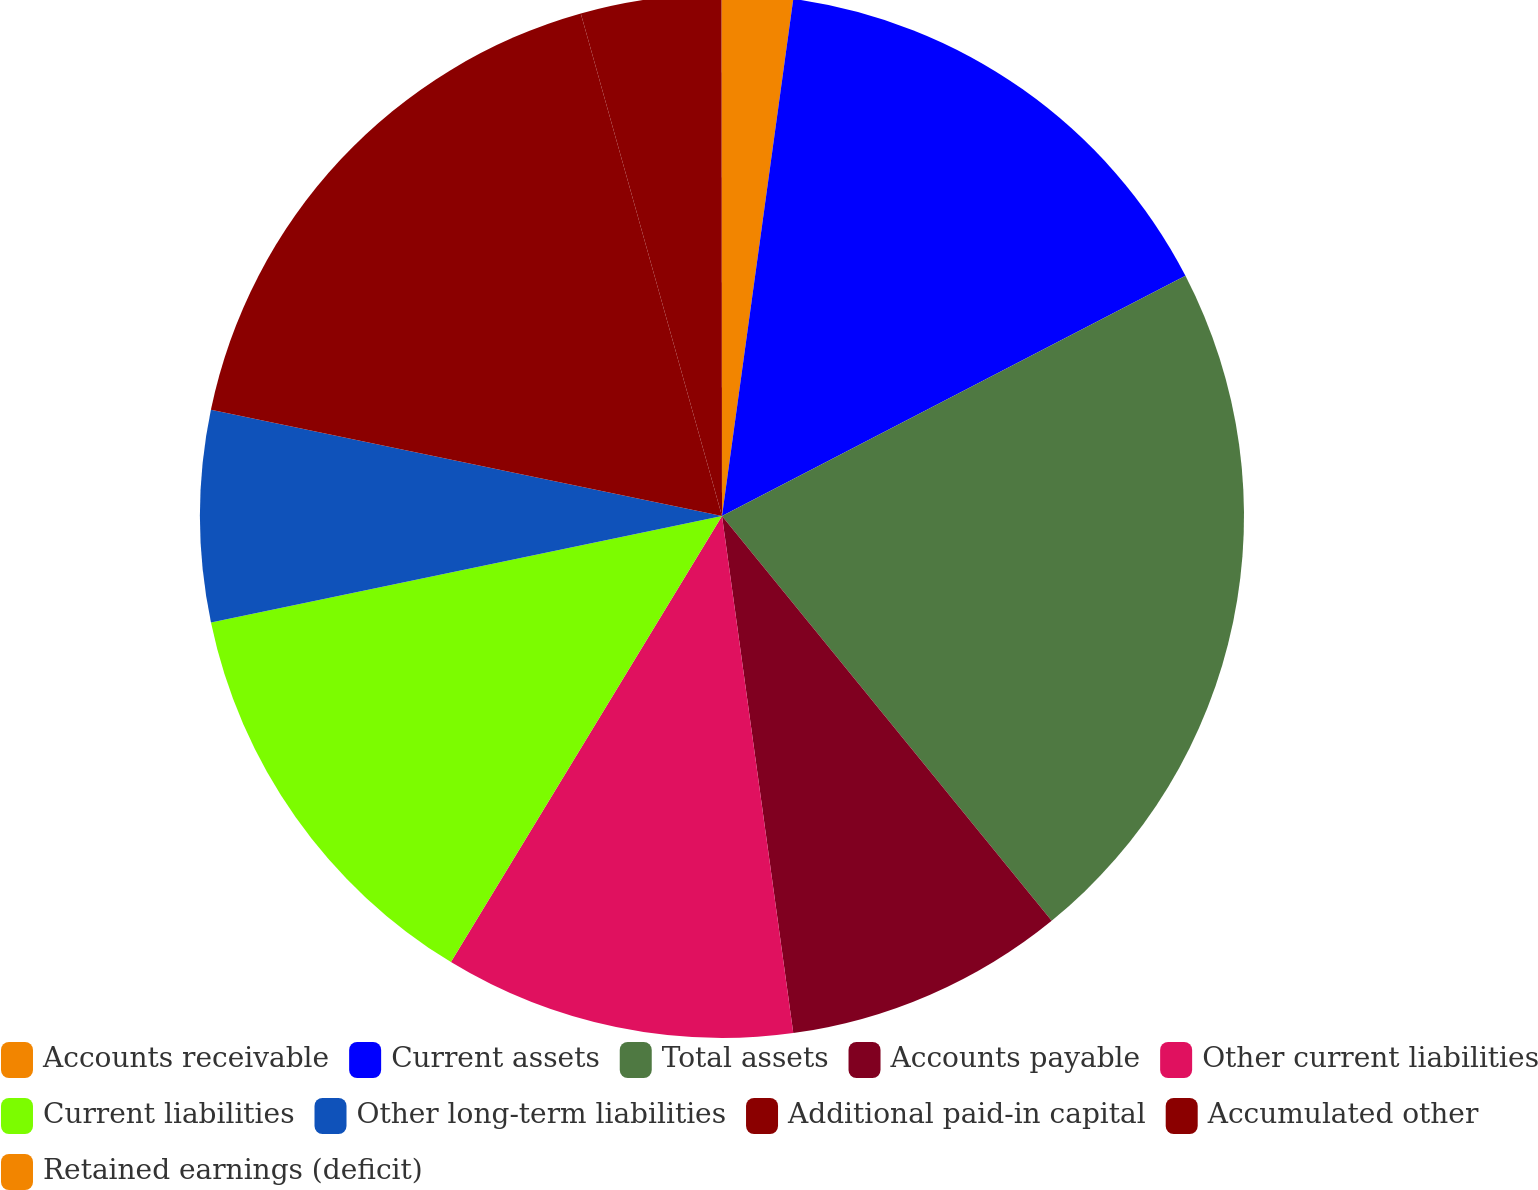<chart> <loc_0><loc_0><loc_500><loc_500><pie_chart><fcel>Accounts receivable<fcel>Current assets<fcel>Total assets<fcel>Accounts payable<fcel>Other current liabilities<fcel>Current liabilities<fcel>Other long-term liabilities<fcel>Additional paid-in capital<fcel>Accumulated other<fcel>Retained earnings (deficit)<nl><fcel>2.18%<fcel>15.21%<fcel>21.73%<fcel>8.7%<fcel>10.87%<fcel>13.04%<fcel>6.53%<fcel>17.38%<fcel>4.35%<fcel>0.01%<nl></chart> 